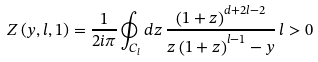Convert formula to latex. <formula><loc_0><loc_0><loc_500><loc_500>Z \left ( y , l , 1 \right ) = \frac { 1 } { 2 i \pi } \oint _ { C _ { l } } d z \, \frac { \left ( 1 + z \right ) ^ { d + 2 l - 2 } } { z \left ( 1 + z \right ) ^ { l - 1 } - y } \, l > 0 \,</formula> 